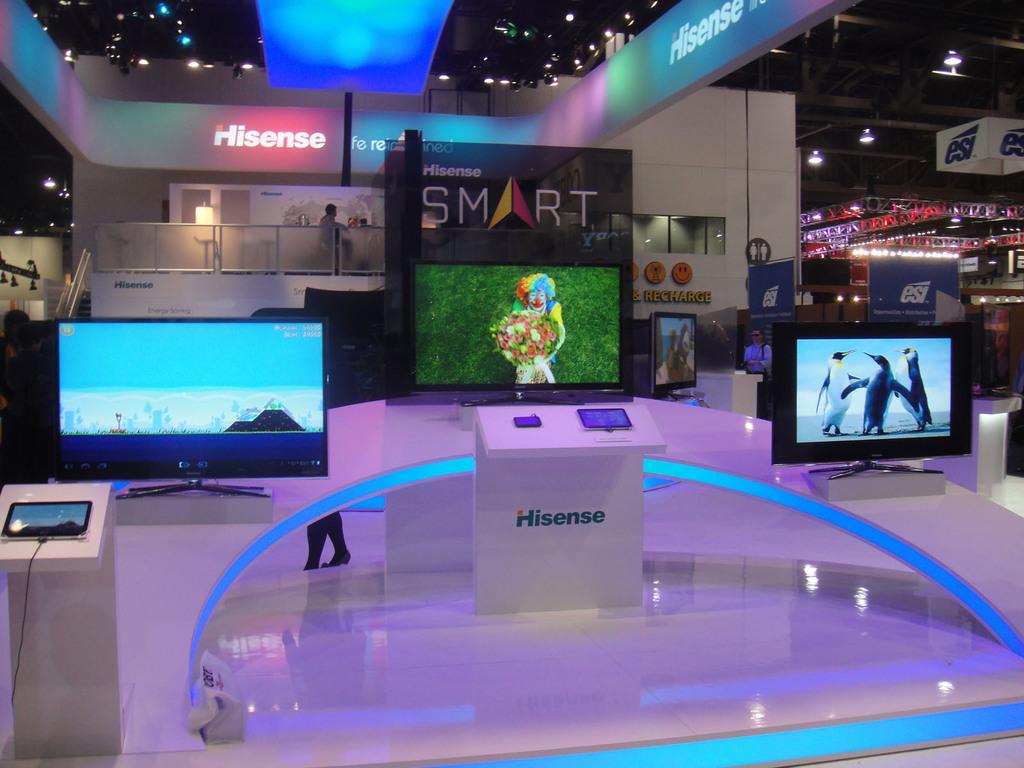What's th epink neon read?
Make the answer very short. Hisense. 